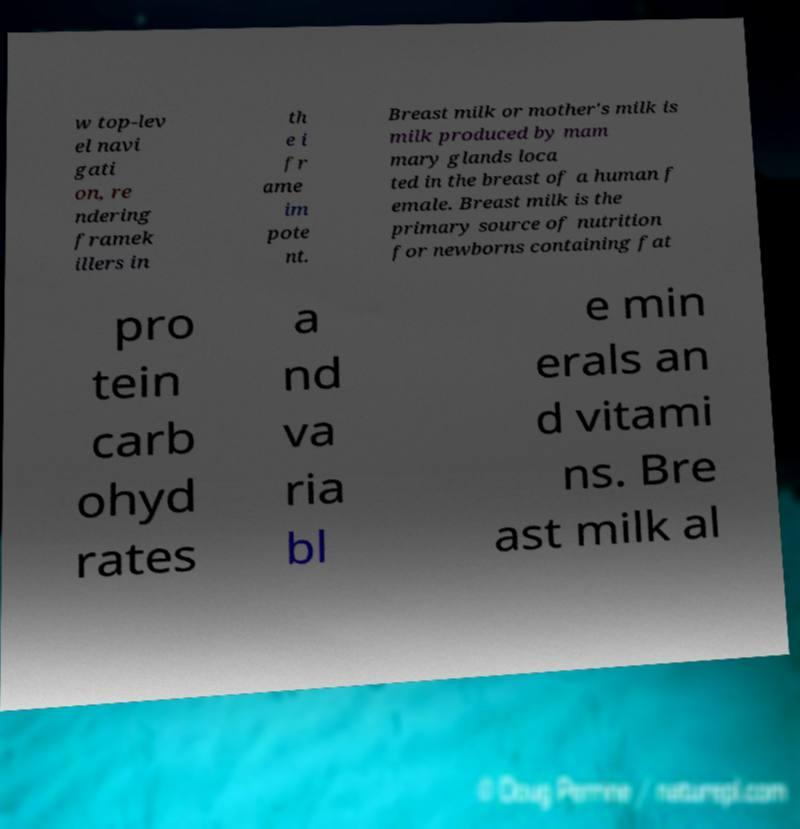Can you accurately transcribe the text from the provided image for me? w top-lev el navi gati on, re ndering framek illers in th e i fr ame im pote nt. Breast milk or mother's milk is milk produced by mam mary glands loca ted in the breast of a human f emale. Breast milk is the primary source of nutrition for newborns containing fat pro tein carb ohyd rates a nd va ria bl e min erals an d vitami ns. Bre ast milk al 